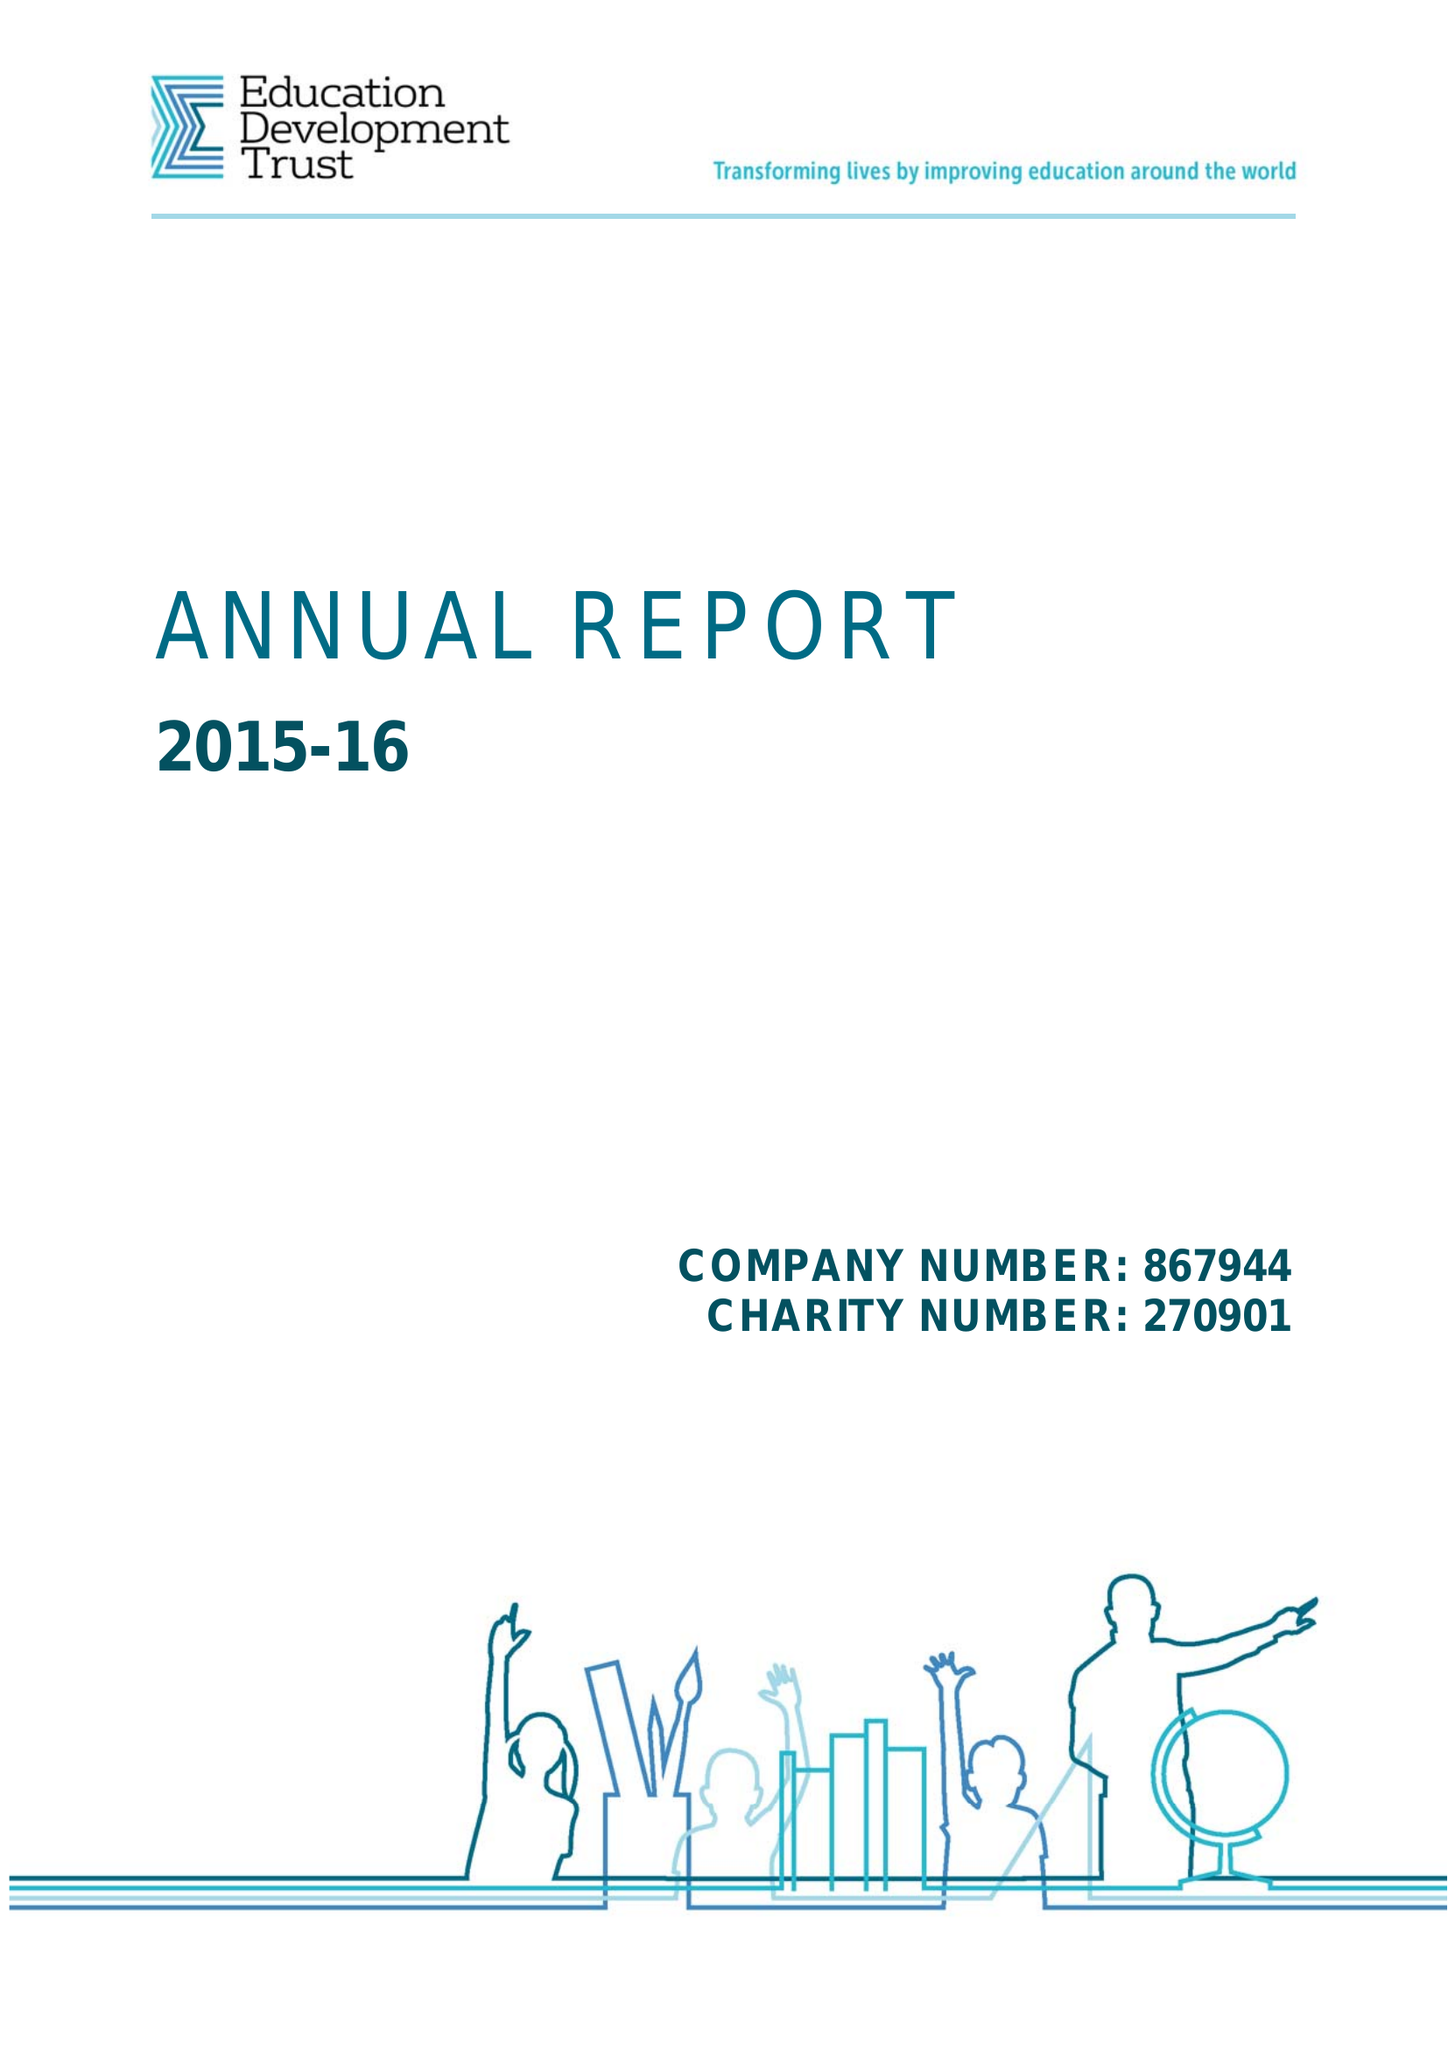What is the value for the report_date?
Answer the question using a single word or phrase. 2016-08-31 